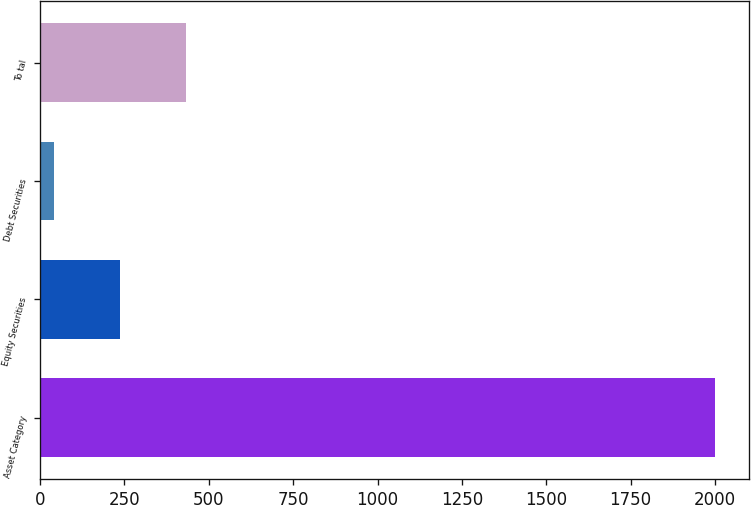<chart> <loc_0><loc_0><loc_500><loc_500><bar_chart><fcel>Asset Category<fcel>Equity Securities<fcel>Debt Securities<fcel>To tal<nl><fcel>2001<fcel>237.9<fcel>42<fcel>433.8<nl></chart> 